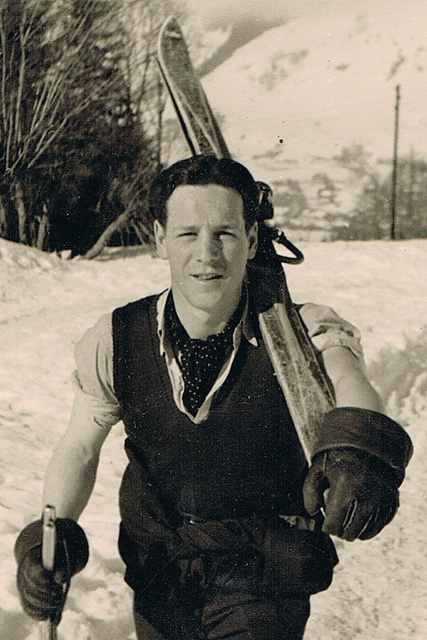Describe the objects in this image and their specific colors. I can see people in gray, black, and darkgray tones and skis in gray, black, and darkgray tones in this image. 